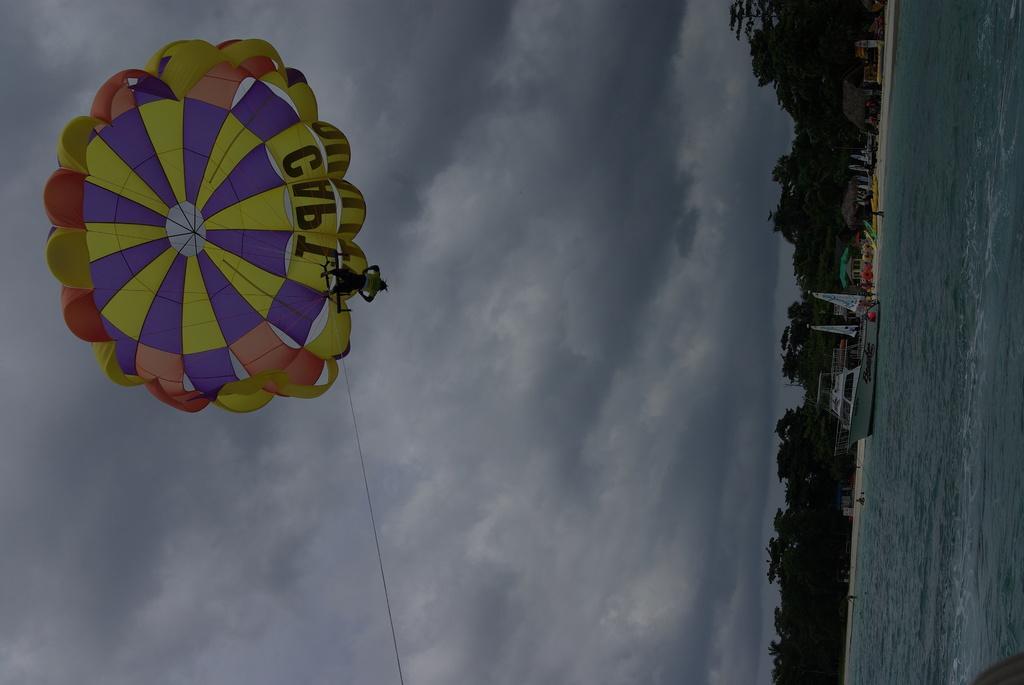Please provide a concise description of this image. In this image, we can see boats on the water and in the background, there are trees. At the top, we can see a parachute. 